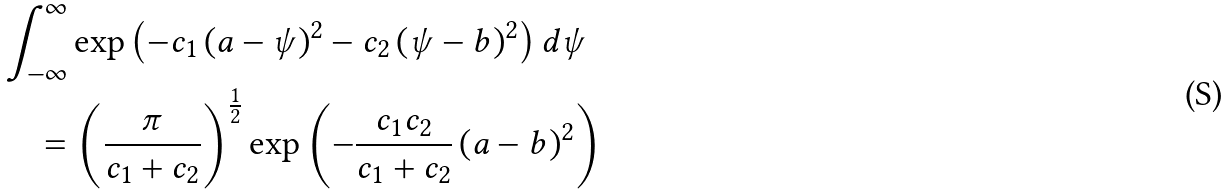Convert formula to latex. <formula><loc_0><loc_0><loc_500><loc_500>& \int _ { - \infty } ^ { \infty } \exp \left ( - c _ { 1 } \left ( a - \psi \right ) ^ { 2 } - c _ { 2 } \left ( \psi - b \right ) ^ { 2 } \right ) d \psi \\ & \quad = \left ( \frac { \pi } { c _ { 1 } + c _ { 2 } } \right ) ^ { \frac { 1 } { 2 } } \exp \left ( - \frac { c _ { 1 } c _ { 2 } } { c _ { 1 } + c _ { 2 } } \left ( a - b \right ) ^ { 2 } \right )</formula> 